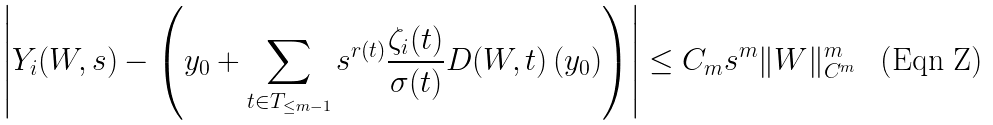Convert formula to latex. <formula><loc_0><loc_0><loc_500><loc_500>\left | Y _ { i } ( W , s ) - \left ( y _ { 0 } + \sum _ { t \in T _ { \leq m - 1 } } s ^ { r ( t ) } \frac { \zeta _ { i } ( t ) } { \sigma ( t ) } D ( W , t ) \left ( y _ { 0 } \right ) \right ) \right | \leq C _ { m } s ^ { m } \| W \| ^ { m } _ { C ^ { m } }</formula> 